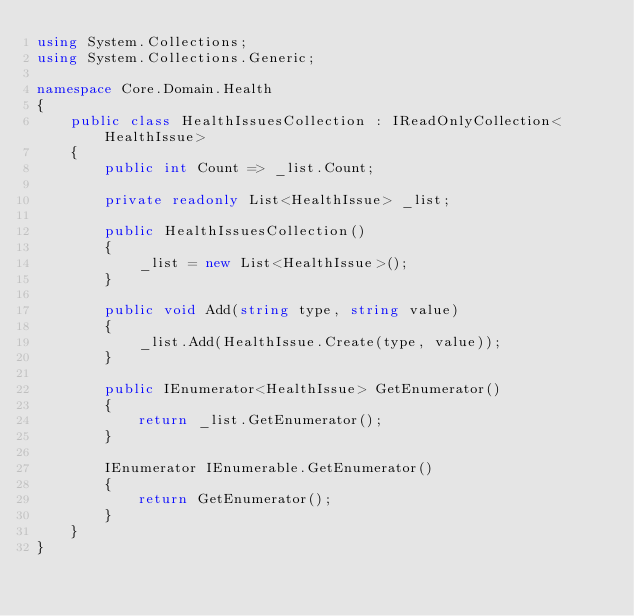Convert code to text. <code><loc_0><loc_0><loc_500><loc_500><_C#_>using System.Collections;
using System.Collections.Generic;

namespace Core.Domain.Health
{
    public class HealthIssuesCollection : IReadOnlyCollection<HealthIssue>
    {
        public int Count => _list.Count;

        private readonly List<HealthIssue> _list;

        public HealthIssuesCollection()
        {
            _list = new List<HealthIssue>();
        }

        public void Add(string type, string value)
        {
            _list.Add(HealthIssue.Create(type, value));
        }

        public IEnumerator<HealthIssue> GetEnumerator()
        {
            return _list.GetEnumerator();
        }

        IEnumerator IEnumerable.GetEnumerator()
        {
            return GetEnumerator();
        }
    }
}</code> 